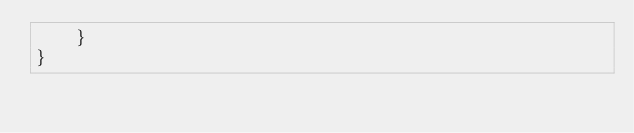<code> <loc_0><loc_0><loc_500><loc_500><_Java_>    }
}
</code> 